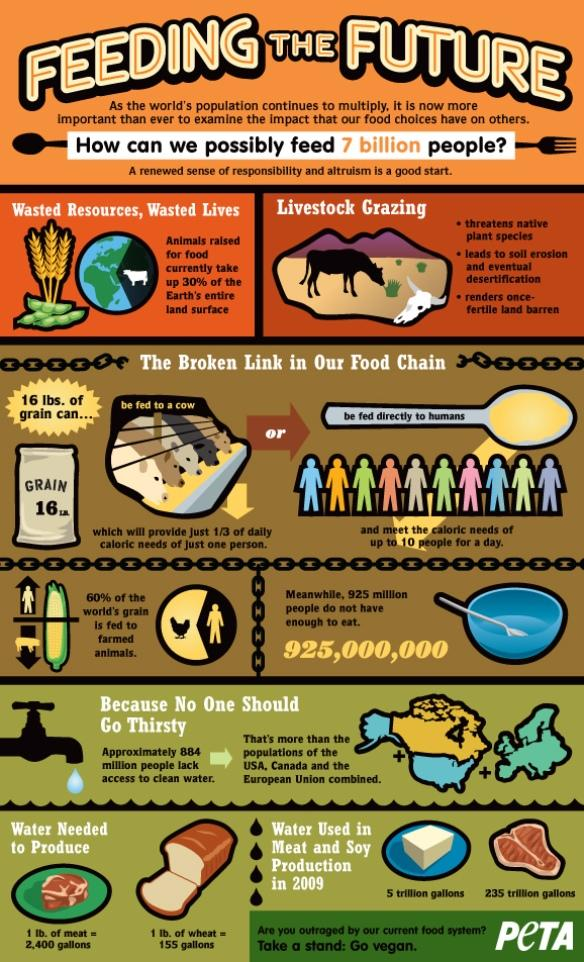Give some essential details in this illustration. It requires approximately 2,400 gallons of water to produce 1 pound of meat. In 2009, it was estimated that the amount of water needed to produce soybeans was approximately 235 trillion gallons. Approximately 40% of the world's grain is not used to feed farmed animals. Approximately 70% of the earth's land surface is not used for raising animals for food. It requires approximately 155 gallons of water to produce 1 pound of wheat. 